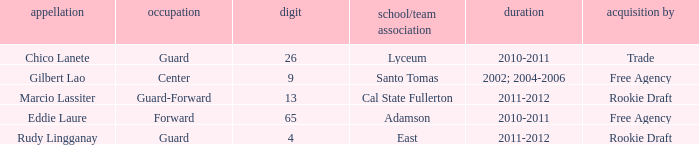What season had Marcio Lassiter? 2011-2012. 